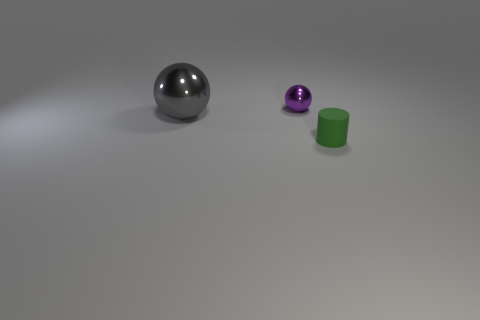Is there anything else that has the same material as the gray object?
Give a very brief answer. Yes. Is the number of metal spheres behind the gray thing less than the number of red rubber cylinders?
Keep it short and to the point. No. What color is the shiny sphere to the left of the ball that is behind the big gray metal ball?
Provide a short and direct response. Gray. What is the size of the rubber object that is in front of the big object that is left of the tiny object left of the rubber object?
Give a very brief answer. Small. Is the number of small purple objects that are behind the purple metal ball less than the number of small green rubber cylinders behind the matte cylinder?
Provide a short and direct response. No. How many small objects have the same material as the tiny sphere?
Offer a very short reply. 0. There is a small object that is right of the small thing behind the green object; is there a large thing that is in front of it?
Your response must be concise. No. There is a tiny object that is made of the same material as the gray ball; what is its shape?
Provide a short and direct response. Sphere. Are there more green rubber objects than small cyan rubber balls?
Provide a succinct answer. Yes. There is a tiny green object; does it have the same shape as the shiny thing that is in front of the tiny ball?
Provide a short and direct response. No. 